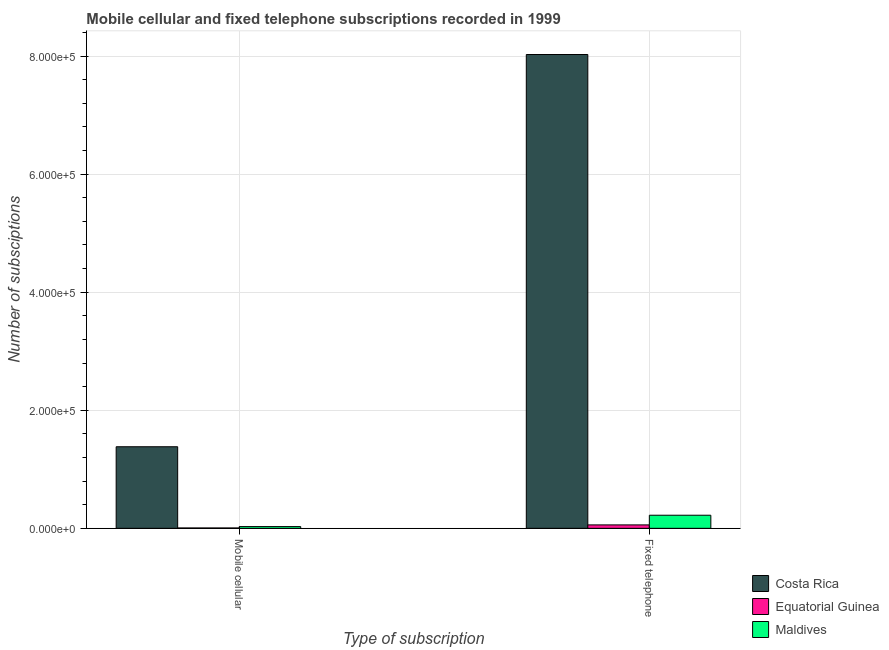How many different coloured bars are there?
Provide a succinct answer. 3. Are the number of bars per tick equal to the number of legend labels?
Your answer should be compact. Yes. Are the number of bars on each tick of the X-axis equal?
Your response must be concise. Yes. What is the label of the 2nd group of bars from the left?
Ensure brevity in your answer.  Fixed telephone. What is the number of fixed telephone subscriptions in Equatorial Guinea?
Provide a succinct answer. 5800. Across all countries, what is the maximum number of fixed telephone subscriptions?
Provide a succinct answer. 8.03e+05. Across all countries, what is the minimum number of mobile cellular subscriptions?
Keep it short and to the point. 600. In which country was the number of fixed telephone subscriptions minimum?
Ensure brevity in your answer.  Equatorial Guinea. What is the total number of fixed telephone subscriptions in the graph?
Make the answer very short. 8.31e+05. What is the difference between the number of fixed telephone subscriptions in Maldives and that in Equatorial Guinea?
Make the answer very short. 1.64e+04. What is the difference between the number of mobile cellular subscriptions in Maldives and the number of fixed telephone subscriptions in Costa Rica?
Offer a terse response. -8.00e+05. What is the average number of mobile cellular subscriptions per country?
Your answer should be very brief. 4.72e+04. What is the difference between the number of fixed telephone subscriptions and number of mobile cellular subscriptions in Equatorial Guinea?
Provide a succinct answer. 5200. In how many countries, is the number of mobile cellular subscriptions greater than 440000 ?
Make the answer very short. 0. What is the ratio of the number of mobile cellular subscriptions in Maldives to that in Costa Rica?
Give a very brief answer. 0.02. Is the number of mobile cellular subscriptions in Costa Rica less than that in Maldives?
Keep it short and to the point. No. What does the 3rd bar from the left in Fixed telephone represents?
Make the answer very short. Maldives. What does the 1st bar from the right in Fixed telephone represents?
Provide a succinct answer. Maldives. Are all the bars in the graph horizontal?
Offer a terse response. No. How many countries are there in the graph?
Offer a terse response. 3. Are the values on the major ticks of Y-axis written in scientific E-notation?
Your response must be concise. Yes. Does the graph contain any zero values?
Keep it short and to the point. No. Does the graph contain grids?
Ensure brevity in your answer.  Yes. Where does the legend appear in the graph?
Give a very brief answer. Bottom right. How many legend labels are there?
Provide a succinct answer. 3. What is the title of the graph?
Give a very brief answer. Mobile cellular and fixed telephone subscriptions recorded in 1999. What is the label or title of the X-axis?
Give a very brief answer. Type of subscription. What is the label or title of the Y-axis?
Provide a succinct answer. Number of subsciptions. What is the Number of subsciptions of Costa Rica in Mobile cellular?
Keep it short and to the point. 1.38e+05. What is the Number of subsciptions in Equatorial Guinea in Mobile cellular?
Offer a very short reply. 600. What is the Number of subsciptions of Maldives in Mobile cellular?
Give a very brief answer. 2926. What is the Number of subsciptions in Costa Rica in Fixed telephone?
Provide a succinct answer. 8.03e+05. What is the Number of subsciptions of Equatorial Guinea in Fixed telephone?
Offer a terse response. 5800. What is the Number of subsciptions in Maldives in Fixed telephone?
Offer a terse response. 2.22e+04. Across all Type of subscription, what is the maximum Number of subsciptions in Costa Rica?
Offer a terse response. 8.03e+05. Across all Type of subscription, what is the maximum Number of subsciptions of Equatorial Guinea?
Your answer should be compact. 5800. Across all Type of subscription, what is the maximum Number of subsciptions of Maldives?
Your response must be concise. 2.22e+04. Across all Type of subscription, what is the minimum Number of subsciptions in Costa Rica?
Ensure brevity in your answer.  1.38e+05. Across all Type of subscription, what is the minimum Number of subsciptions in Equatorial Guinea?
Your answer should be very brief. 600. Across all Type of subscription, what is the minimum Number of subsciptions in Maldives?
Make the answer very short. 2926. What is the total Number of subsciptions of Costa Rica in the graph?
Your response must be concise. 9.41e+05. What is the total Number of subsciptions of Equatorial Guinea in the graph?
Keep it short and to the point. 6400. What is the total Number of subsciptions of Maldives in the graph?
Keep it short and to the point. 2.51e+04. What is the difference between the Number of subsciptions in Costa Rica in Mobile cellular and that in Fixed telephone?
Keep it short and to the point. -6.64e+05. What is the difference between the Number of subsciptions of Equatorial Guinea in Mobile cellular and that in Fixed telephone?
Your answer should be very brief. -5200. What is the difference between the Number of subsciptions in Maldives in Mobile cellular and that in Fixed telephone?
Offer a terse response. -1.93e+04. What is the difference between the Number of subsciptions of Costa Rica in Mobile cellular and the Number of subsciptions of Equatorial Guinea in Fixed telephone?
Give a very brief answer. 1.32e+05. What is the difference between the Number of subsciptions in Costa Rica in Mobile cellular and the Number of subsciptions in Maldives in Fixed telephone?
Provide a short and direct response. 1.16e+05. What is the difference between the Number of subsciptions in Equatorial Guinea in Mobile cellular and the Number of subsciptions in Maldives in Fixed telephone?
Ensure brevity in your answer.  -2.16e+04. What is the average Number of subsciptions of Costa Rica per Type of subscription?
Your response must be concise. 4.70e+05. What is the average Number of subsciptions in Equatorial Guinea per Type of subscription?
Your response must be concise. 3200. What is the average Number of subsciptions of Maldives per Type of subscription?
Ensure brevity in your answer.  1.26e+04. What is the difference between the Number of subsciptions of Costa Rica and Number of subsciptions of Equatorial Guinea in Mobile cellular?
Offer a terse response. 1.38e+05. What is the difference between the Number of subsciptions in Costa Rica and Number of subsciptions in Maldives in Mobile cellular?
Ensure brevity in your answer.  1.35e+05. What is the difference between the Number of subsciptions of Equatorial Guinea and Number of subsciptions of Maldives in Mobile cellular?
Ensure brevity in your answer.  -2326. What is the difference between the Number of subsciptions in Costa Rica and Number of subsciptions in Equatorial Guinea in Fixed telephone?
Give a very brief answer. 7.97e+05. What is the difference between the Number of subsciptions in Costa Rica and Number of subsciptions in Maldives in Fixed telephone?
Offer a very short reply. 7.80e+05. What is the difference between the Number of subsciptions in Equatorial Guinea and Number of subsciptions in Maldives in Fixed telephone?
Your response must be concise. -1.64e+04. What is the ratio of the Number of subsciptions of Costa Rica in Mobile cellular to that in Fixed telephone?
Offer a terse response. 0.17. What is the ratio of the Number of subsciptions in Equatorial Guinea in Mobile cellular to that in Fixed telephone?
Make the answer very short. 0.1. What is the ratio of the Number of subsciptions in Maldives in Mobile cellular to that in Fixed telephone?
Your answer should be compact. 0.13. What is the difference between the highest and the second highest Number of subsciptions in Costa Rica?
Ensure brevity in your answer.  6.64e+05. What is the difference between the highest and the second highest Number of subsciptions in Equatorial Guinea?
Ensure brevity in your answer.  5200. What is the difference between the highest and the second highest Number of subsciptions in Maldives?
Offer a terse response. 1.93e+04. What is the difference between the highest and the lowest Number of subsciptions of Costa Rica?
Keep it short and to the point. 6.64e+05. What is the difference between the highest and the lowest Number of subsciptions of Equatorial Guinea?
Keep it short and to the point. 5200. What is the difference between the highest and the lowest Number of subsciptions in Maldives?
Give a very brief answer. 1.93e+04. 